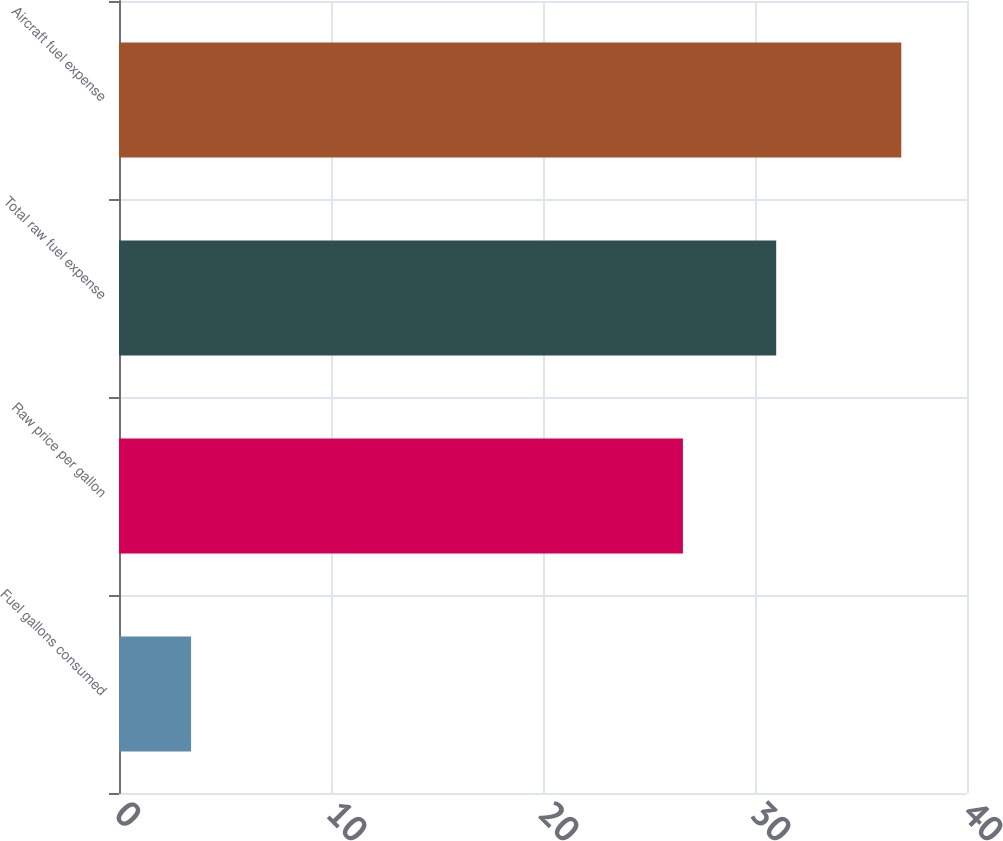Convert chart. <chart><loc_0><loc_0><loc_500><loc_500><bar_chart><fcel>Fuel gallons consumed<fcel>Raw price per gallon<fcel>Total raw fuel expense<fcel>Aircraft fuel expense<nl><fcel>3.4<fcel>26.6<fcel>31<fcel>36.9<nl></chart> 